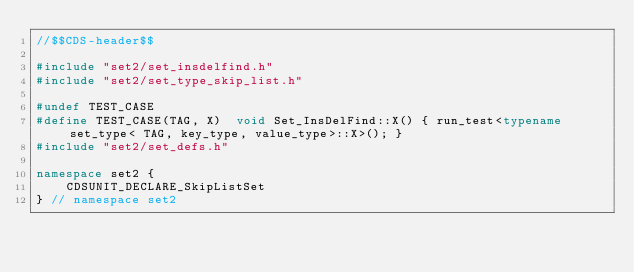<code> <loc_0><loc_0><loc_500><loc_500><_C++_>//$$CDS-header$$

#include "set2/set_insdelfind.h"
#include "set2/set_type_skip_list.h"

#undef TEST_CASE
#define TEST_CASE(TAG, X)  void Set_InsDelFind::X() { run_test<typename set_type< TAG, key_type, value_type>::X>(); }
#include "set2/set_defs.h"

namespace set2 {
    CDSUNIT_DECLARE_SkipListSet
} // namespace set2
</code> 